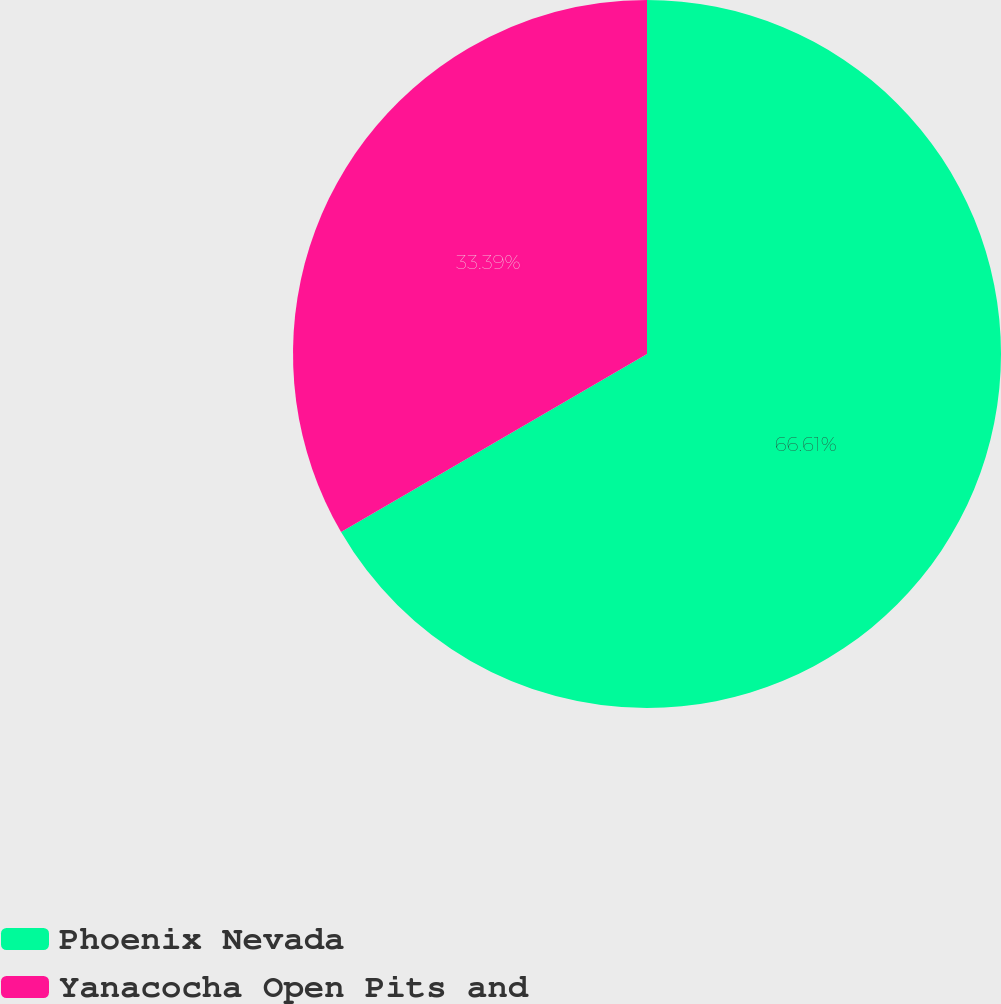Convert chart to OTSL. <chart><loc_0><loc_0><loc_500><loc_500><pie_chart><fcel>Phoenix Nevada<fcel>Yanacocha Open Pits and<nl><fcel>66.61%<fcel>33.39%<nl></chart> 